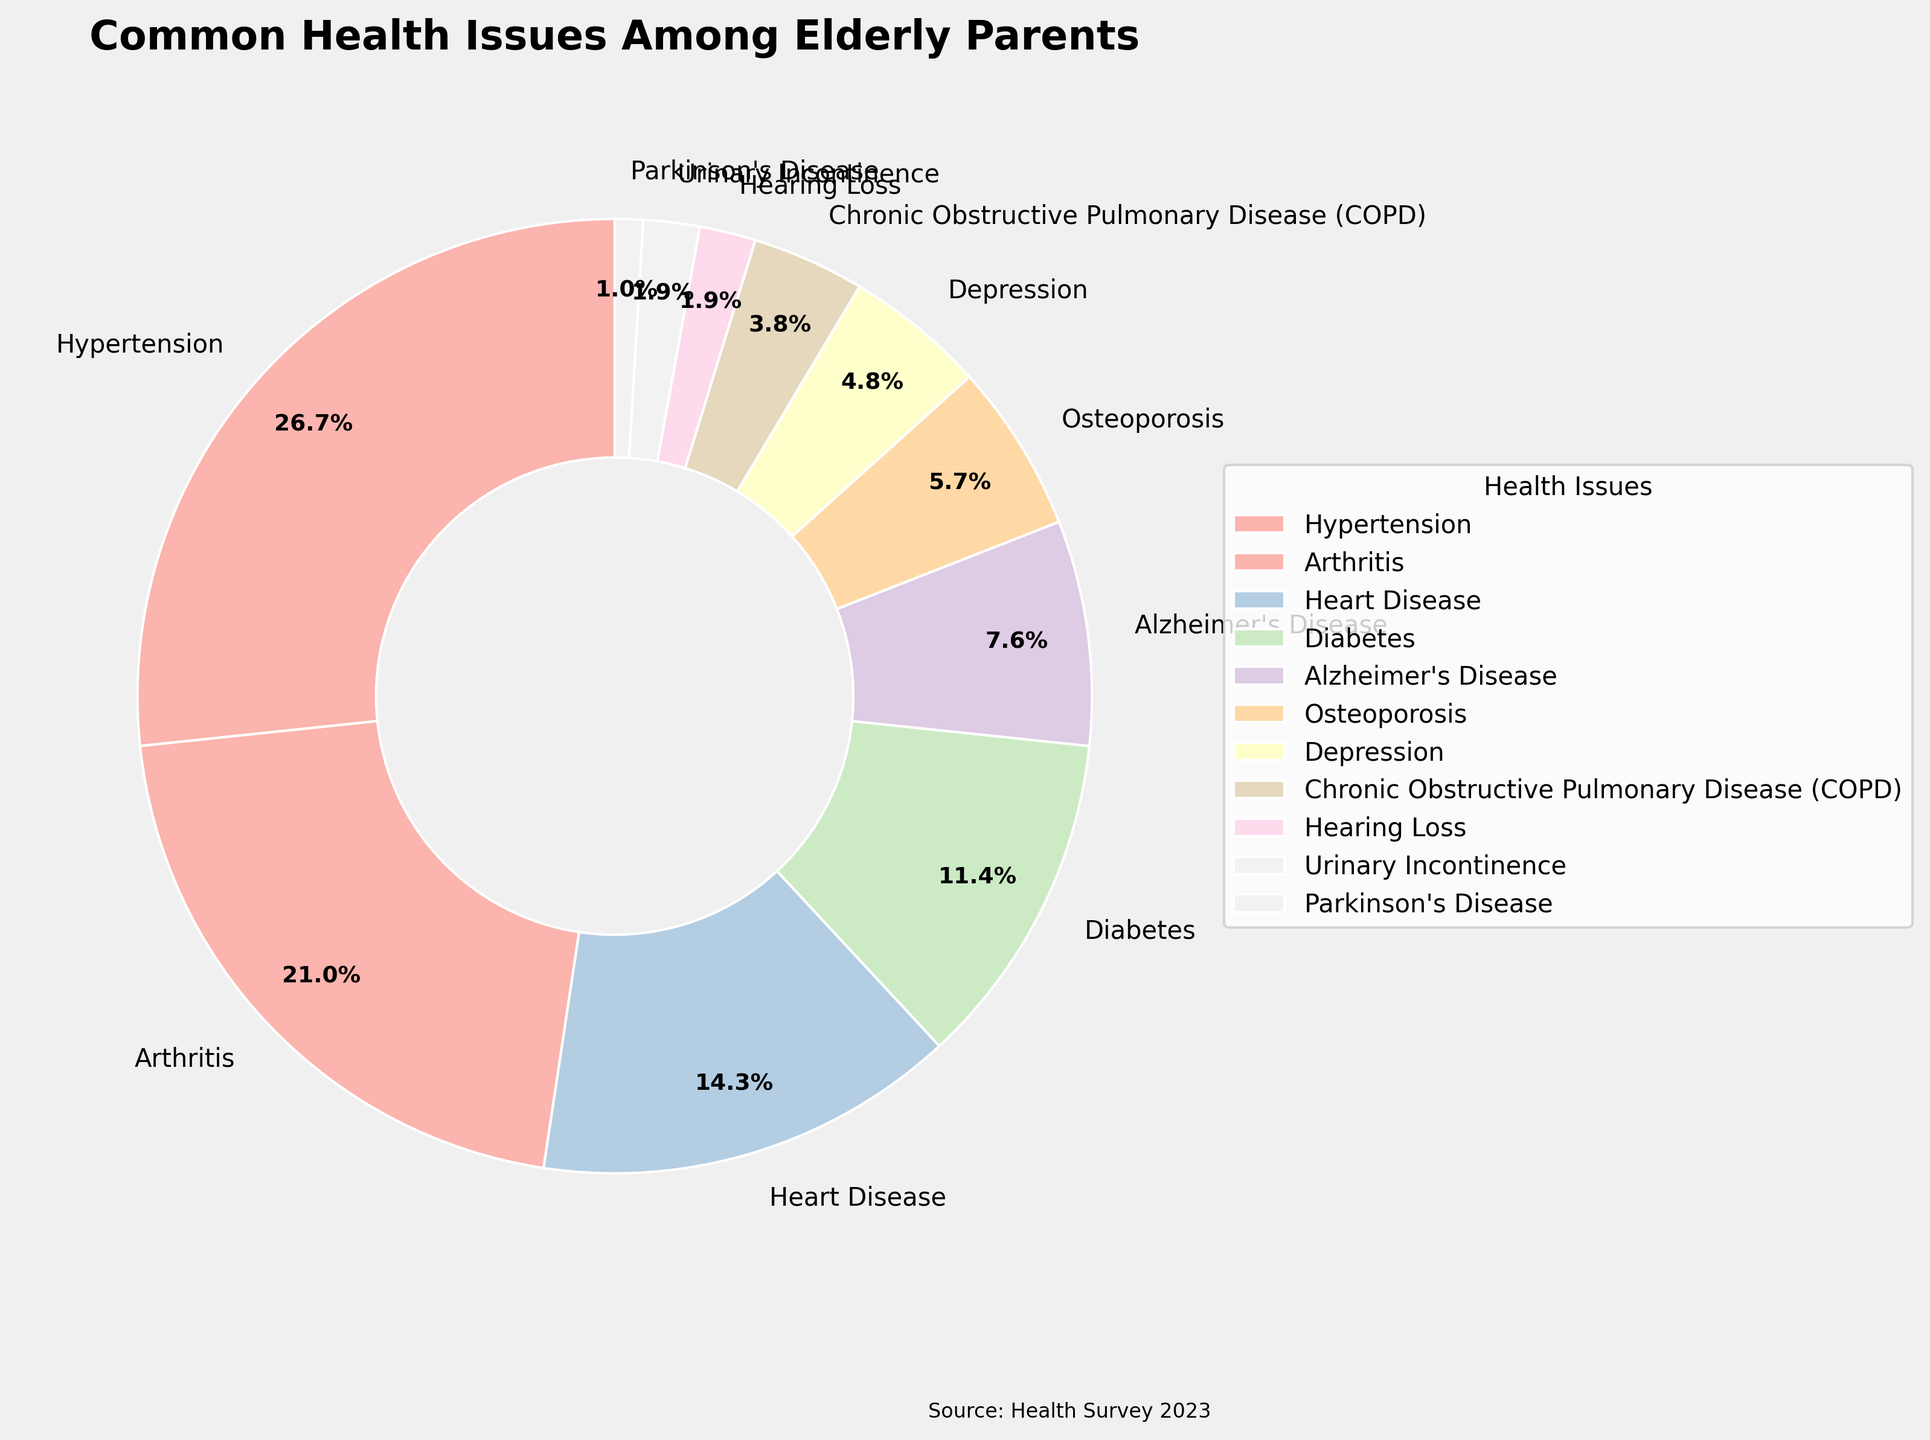What's the most common health issue among elderly parents? Look at the pie chart's largest section based on percentage. Hypertension has the largest slice at 28%, making it the most common issue.
Answer: Hypertension Which health issue is more common, Diabetes or Arthritis? Compare the percentages of Diabetes and Arthritis. Diabetes is at 12%, while Arthritis is at 22%. Since 22% is greater than 12%, Arthritis is more common.
Answer: Arthritis What percentage of elderly parents suffer from Heart Disease and Alzheimer's Disease combined? Sum the percentages of Heart Disease (15%) and Alzheimer's Disease (8%). 15 + 8 equals 23. Hence, the combined percentage is 23%.
Answer: 23% Is Osteoporosis less common than Diabetes? Compare the percentages of Osteoporosis and Diabetes. Osteoporosis is at 6%, while Diabetes is at 12%. Since 6% is less than 12%, Osteoporosis is indeed less common than Diabetes.
Answer: Yes How does the prevalence of Depression compare to Chronic Obstructive Pulmonary Disease (COPD)? Look at the percentages for Depression (5%) and COPD (4%). Depression's 5% is greater than COPD's 4%, indicating that Depression is more prevalent.
Answer: Depression What is the combined percentage for health issues that affect less than 5% of elderly parents? Identify the issues with less than 5%: COPD (4%), Hearing Loss (2%), Urinary Incontinence (2%), and Parkinson's Disease (1%). Add these percentages: 4 + 2 + 2 + 1 equals 9%.
Answer: 9% Which health issue has the smallest percentage? Find the smallest wedge in the pie chart. Parkinson's Disease has the smallest percentage at 1%.
Answer: Parkinson's Disease Among the health issues listed, which ones have percentages above 20%? Identify the health issues with percentages higher than 20%. Hypertension is at 28% and Arthritis is at 22%.
Answer: Hypertension, Arthritis What is the difference in percentage between Heart Disease and Osteoporosis? Subtract the percentage of Osteoporosis (6%) from the percentage of Heart Disease (15%). 15 - 6 equals 9%.
Answer: 9% How does the visual representation of Hypertension compare with Depression? Look at the size of wedges. Hypertension's wedge is larger and covers more area at 28%, compared to the smaller wedge of Depression at 5%.
Answer: Hypertension has a larger visual representation 